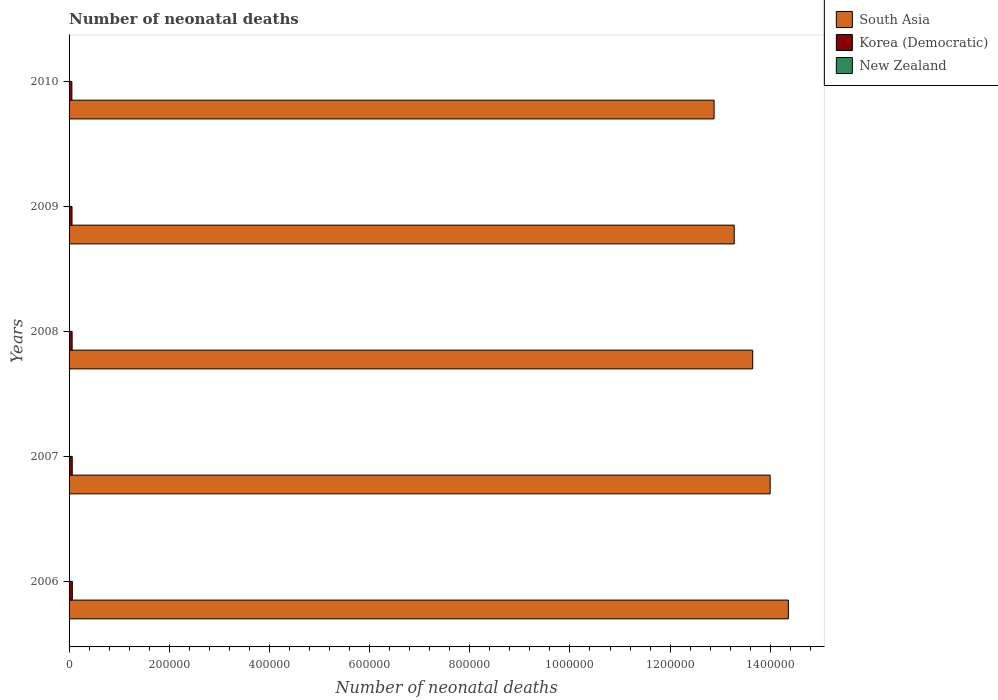How many different coloured bars are there?
Keep it short and to the point. 3. Are the number of bars per tick equal to the number of legend labels?
Offer a very short reply. Yes. How many bars are there on the 2nd tick from the bottom?
Keep it short and to the point. 3. What is the label of the 1st group of bars from the top?
Ensure brevity in your answer.  2010. What is the number of neonatal deaths in in New Zealand in 2007?
Offer a terse response. 189. Across all years, what is the maximum number of neonatal deaths in in New Zealand?
Give a very brief answer. 222. Across all years, what is the minimum number of neonatal deaths in in South Asia?
Your answer should be compact. 1.29e+06. In which year was the number of neonatal deaths in in Korea (Democratic) maximum?
Make the answer very short. 2006. In which year was the number of neonatal deaths in in South Asia minimum?
Provide a succinct answer. 2010. What is the total number of neonatal deaths in in New Zealand in the graph?
Offer a very short reply. 1009. What is the difference between the number of neonatal deaths in in New Zealand in 2006 and that in 2007?
Your answer should be compact. -6. What is the difference between the number of neonatal deaths in in South Asia in 2006 and the number of neonatal deaths in in New Zealand in 2008?
Provide a short and direct response. 1.44e+06. What is the average number of neonatal deaths in in Korea (Democratic) per year?
Your response must be concise. 6083.8. In the year 2007, what is the difference between the number of neonatal deaths in in South Asia and number of neonatal deaths in in Korea (Democratic)?
Offer a terse response. 1.39e+06. In how many years, is the number of neonatal deaths in in Korea (Democratic) greater than 880000 ?
Your response must be concise. 0. What is the ratio of the number of neonatal deaths in in South Asia in 2007 to that in 2010?
Provide a short and direct response. 1.09. What is the difference between the highest and the second highest number of neonatal deaths in in New Zealand?
Your response must be concise. 9. What is the difference between the highest and the lowest number of neonatal deaths in in South Asia?
Ensure brevity in your answer.  1.48e+05. In how many years, is the number of neonatal deaths in in Korea (Democratic) greater than the average number of neonatal deaths in in Korea (Democratic) taken over all years?
Provide a short and direct response. 3. Is the sum of the number of neonatal deaths in in New Zealand in 2008 and 2010 greater than the maximum number of neonatal deaths in in South Asia across all years?
Provide a succinct answer. No. Is it the case that in every year, the sum of the number of neonatal deaths in in Korea (Democratic) and number of neonatal deaths in in South Asia is greater than the number of neonatal deaths in in New Zealand?
Offer a very short reply. Yes. How many bars are there?
Keep it short and to the point. 15. How many years are there in the graph?
Keep it short and to the point. 5. What is the difference between two consecutive major ticks on the X-axis?
Offer a very short reply. 2.00e+05. Does the graph contain grids?
Keep it short and to the point. No. How many legend labels are there?
Your answer should be compact. 3. What is the title of the graph?
Offer a terse response. Number of neonatal deaths. Does "Sub-Saharan Africa (developing only)" appear as one of the legend labels in the graph?
Keep it short and to the point. No. What is the label or title of the X-axis?
Ensure brevity in your answer.  Number of neonatal deaths. What is the Number of neonatal deaths in South Asia in 2006?
Ensure brevity in your answer.  1.44e+06. What is the Number of neonatal deaths in Korea (Democratic) in 2006?
Provide a succinct answer. 6530. What is the Number of neonatal deaths of New Zealand in 2006?
Offer a very short reply. 183. What is the Number of neonatal deaths in South Asia in 2007?
Your answer should be very brief. 1.40e+06. What is the Number of neonatal deaths in Korea (Democratic) in 2007?
Your answer should be compact. 6308. What is the Number of neonatal deaths of New Zealand in 2007?
Keep it short and to the point. 189. What is the Number of neonatal deaths of South Asia in 2008?
Make the answer very short. 1.36e+06. What is the Number of neonatal deaths in Korea (Democratic) in 2008?
Your response must be concise. 6101. What is the Number of neonatal deaths of New Zealand in 2008?
Keep it short and to the point. 202. What is the Number of neonatal deaths of South Asia in 2009?
Provide a succinct answer. 1.33e+06. What is the Number of neonatal deaths in Korea (Democratic) in 2009?
Make the answer very short. 5845. What is the Number of neonatal deaths in New Zealand in 2009?
Provide a succinct answer. 213. What is the Number of neonatal deaths in South Asia in 2010?
Your response must be concise. 1.29e+06. What is the Number of neonatal deaths of Korea (Democratic) in 2010?
Offer a terse response. 5635. What is the Number of neonatal deaths in New Zealand in 2010?
Provide a succinct answer. 222. Across all years, what is the maximum Number of neonatal deaths in South Asia?
Ensure brevity in your answer.  1.44e+06. Across all years, what is the maximum Number of neonatal deaths of Korea (Democratic)?
Offer a terse response. 6530. Across all years, what is the maximum Number of neonatal deaths of New Zealand?
Keep it short and to the point. 222. Across all years, what is the minimum Number of neonatal deaths in South Asia?
Ensure brevity in your answer.  1.29e+06. Across all years, what is the minimum Number of neonatal deaths of Korea (Democratic)?
Ensure brevity in your answer.  5635. Across all years, what is the minimum Number of neonatal deaths of New Zealand?
Your answer should be very brief. 183. What is the total Number of neonatal deaths of South Asia in the graph?
Provide a short and direct response. 6.82e+06. What is the total Number of neonatal deaths in Korea (Democratic) in the graph?
Your answer should be compact. 3.04e+04. What is the total Number of neonatal deaths in New Zealand in the graph?
Keep it short and to the point. 1009. What is the difference between the Number of neonatal deaths in South Asia in 2006 and that in 2007?
Provide a succinct answer. 3.64e+04. What is the difference between the Number of neonatal deaths in Korea (Democratic) in 2006 and that in 2007?
Make the answer very short. 222. What is the difference between the Number of neonatal deaths of New Zealand in 2006 and that in 2007?
Your response must be concise. -6. What is the difference between the Number of neonatal deaths in South Asia in 2006 and that in 2008?
Give a very brief answer. 7.12e+04. What is the difference between the Number of neonatal deaths of Korea (Democratic) in 2006 and that in 2008?
Your response must be concise. 429. What is the difference between the Number of neonatal deaths of New Zealand in 2006 and that in 2008?
Your response must be concise. -19. What is the difference between the Number of neonatal deaths of South Asia in 2006 and that in 2009?
Your response must be concise. 1.08e+05. What is the difference between the Number of neonatal deaths of Korea (Democratic) in 2006 and that in 2009?
Your response must be concise. 685. What is the difference between the Number of neonatal deaths in South Asia in 2006 and that in 2010?
Offer a terse response. 1.48e+05. What is the difference between the Number of neonatal deaths in Korea (Democratic) in 2006 and that in 2010?
Your answer should be compact. 895. What is the difference between the Number of neonatal deaths in New Zealand in 2006 and that in 2010?
Keep it short and to the point. -39. What is the difference between the Number of neonatal deaths in South Asia in 2007 and that in 2008?
Your answer should be compact. 3.48e+04. What is the difference between the Number of neonatal deaths of Korea (Democratic) in 2007 and that in 2008?
Ensure brevity in your answer.  207. What is the difference between the Number of neonatal deaths of New Zealand in 2007 and that in 2008?
Make the answer very short. -13. What is the difference between the Number of neonatal deaths in South Asia in 2007 and that in 2009?
Ensure brevity in your answer.  7.17e+04. What is the difference between the Number of neonatal deaths in Korea (Democratic) in 2007 and that in 2009?
Give a very brief answer. 463. What is the difference between the Number of neonatal deaths in South Asia in 2007 and that in 2010?
Your answer should be very brief. 1.12e+05. What is the difference between the Number of neonatal deaths of Korea (Democratic) in 2007 and that in 2010?
Your answer should be very brief. 673. What is the difference between the Number of neonatal deaths of New Zealand in 2007 and that in 2010?
Ensure brevity in your answer.  -33. What is the difference between the Number of neonatal deaths in South Asia in 2008 and that in 2009?
Your answer should be compact. 3.69e+04. What is the difference between the Number of neonatal deaths in Korea (Democratic) in 2008 and that in 2009?
Your answer should be very brief. 256. What is the difference between the Number of neonatal deaths of South Asia in 2008 and that in 2010?
Provide a short and direct response. 7.71e+04. What is the difference between the Number of neonatal deaths of Korea (Democratic) in 2008 and that in 2010?
Make the answer very short. 466. What is the difference between the Number of neonatal deaths of New Zealand in 2008 and that in 2010?
Offer a very short reply. -20. What is the difference between the Number of neonatal deaths of South Asia in 2009 and that in 2010?
Give a very brief answer. 4.02e+04. What is the difference between the Number of neonatal deaths of Korea (Democratic) in 2009 and that in 2010?
Provide a succinct answer. 210. What is the difference between the Number of neonatal deaths of South Asia in 2006 and the Number of neonatal deaths of Korea (Democratic) in 2007?
Your answer should be compact. 1.43e+06. What is the difference between the Number of neonatal deaths of South Asia in 2006 and the Number of neonatal deaths of New Zealand in 2007?
Make the answer very short. 1.44e+06. What is the difference between the Number of neonatal deaths in Korea (Democratic) in 2006 and the Number of neonatal deaths in New Zealand in 2007?
Keep it short and to the point. 6341. What is the difference between the Number of neonatal deaths of South Asia in 2006 and the Number of neonatal deaths of Korea (Democratic) in 2008?
Your answer should be very brief. 1.43e+06. What is the difference between the Number of neonatal deaths of South Asia in 2006 and the Number of neonatal deaths of New Zealand in 2008?
Provide a succinct answer. 1.44e+06. What is the difference between the Number of neonatal deaths of Korea (Democratic) in 2006 and the Number of neonatal deaths of New Zealand in 2008?
Provide a short and direct response. 6328. What is the difference between the Number of neonatal deaths in South Asia in 2006 and the Number of neonatal deaths in Korea (Democratic) in 2009?
Keep it short and to the point. 1.43e+06. What is the difference between the Number of neonatal deaths in South Asia in 2006 and the Number of neonatal deaths in New Zealand in 2009?
Provide a succinct answer. 1.44e+06. What is the difference between the Number of neonatal deaths of Korea (Democratic) in 2006 and the Number of neonatal deaths of New Zealand in 2009?
Make the answer very short. 6317. What is the difference between the Number of neonatal deaths of South Asia in 2006 and the Number of neonatal deaths of Korea (Democratic) in 2010?
Your answer should be very brief. 1.43e+06. What is the difference between the Number of neonatal deaths of South Asia in 2006 and the Number of neonatal deaths of New Zealand in 2010?
Your answer should be compact. 1.44e+06. What is the difference between the Number of neonatal deaths of Korea (Democratic) in 2006 and the Number of neonatal deaths of New Zealand in 2010?
Keep it short and to the point. 6308. What is the difference between the Number of neonatal deaths of South Asia in 2007 and the Number of neonatal deaths of Korea (Democratic) in 2008?
Ensure brevity in your answer.  1.39e+06. What is the difference between the Number of neonatal deaths of South Asia in 2007 and the Number of neonatal deaths of New Zealand in 2008?
Keep it short and to the point. 1.40e+06. What is the difference between the Number of neonatal deaths in Korea (Democratic) in 2007 and the Number of neonatal deaths in New Zealand in 2008?
Offer a terse response. 6106. What is the difference between the Number of neonatal deaths of South Asia in 2007 and the Number of neonatal deaths of Korea (Democratic) in 2009?
Offer a very short reply. 1.39e+06. What is the difference between the Number of neonatal deaths of South Asia in 2007 and the Number of neonatal deaths of New Zealand in 2009?
Offer a terse response. 1.40e+06. What is the difference between the Number of neonatal deaths in Korea (Democratic) in 2007 and the Number of neonatal deaths in New Zealand in 2009?
Make the answer very short. 6095. What is the difference between the Number of neonatal deaths of South Asia in 2007 and the Number of neonatal deaths of Korea (Democratic) in 2010?
Your answer should be very brief. 1.39e+06. What is the difference between the Number of neonatal deaths of South Asia in 2007 and the Number of neonatal deaths of New Zealand in 2010?
Ensure brevity in your answer.  1.40e+06. What is the difference between the Number of neonatal deaths in Korea (Democratic) in 2007 and the Number of neonatal deaths in New Zealand in 2010?
Keep it short and to the point. 6086. What is the difference between the Number of neonatal deaths of South Asia in 2008 and the Number of neonatal deaths of Korea (Democratic) in 2009?
Your answer should be very brief. 1.36e+06. What is the difference between the Number of neonatal deaths of South Asia in 2008 and the Number of neonatal deaths of New Zealand in 2009?
Offer a very short reply. 1.36e+06. What is the difference between the Number of neonatal deaths of Korea (Democratic) in 2008 and the Number of neonatal deaths of New Zealand in 2009?
Your answer should be very brief. 5888. What is the difference between the Number of neonatal deaths of South Asia in 2008 and the Number of neonatal deaths of Korea (Democratic) in 2010?
Your answer should be compact. 1.36e+06. What is the difference between the Number of neonatal deaths of South Asia in 2008 and the Number of neonatal deaths of New Zealand in 2010?
Make the answer very short. 1.36e+06. What is the difference between the Number of neonatal deaths in Korea (Democratic) in 2008 and the Number of neonatal deaths in New Zealand in 2010?
Keep it short and to the point. 5879. What is the difference between the Number of neonatal deaths in South Asia in 2009 and the Number of neonatal deaths in Korea (Democratic) in 2010?
Your answer should be very brief. 1.32e+06. What is the difference between the Number of neonatal deaths of South Asia in 2009 and the Number of neonatal deaths of New Zealand in 2010?
Provide a short and direct response. 1.33e+06. What is the difference between the Number of neonatal deaths of Korea (Democratic) in 2009 and the Number of neonatal deaths of New Zealand in 2010?
Your answer should be compact. 5623. What is the average Number of neonatal deaths of South Asia per year?
Give a very brief answer. 1.36e+06. What is the average Number of neonatal deaths in Korea (Democratic) per year?
Your answer should be very brief. 6083.8. What is the average Number of neonatal deaths in New Zealand per year?
Your answer should be very brief. 201.8. In the year 2006, what is the difference between the Number of neonatal deaths in South Asia and Number of neonatal deaths in Korea (Democratic)?
Your response must be concise. 1.43e+06. In the year 2006, what is the difference between the Number of neonatal deaths of South Asia and Number of neonatal deaths of New Zealand?
Make the answer very short. 1.44e+06. In the year 2006, what is the difference between the Number of neonatal deaths of Korea (Democratic) and Number of neonatal deaths of New Zealand?
Keep it short and to the point. 6347. In the year 2007, what is the difference between the Number of neonatal deaths of South Asia and Number of neonatal deaths of Korea (Democratic)?
Ensure brevity in your answer.  1.39e+06. In the year 2007, what is the difference between the Number of neonatal deaths of South Asia and Number of neonatal deaths of New Zealand?
Provide a short and direct response. 1.40e+06. In the year 2007, what is the difference between the Number of neonatal deaths in Korea (Democratic) and Number of neonatal deaths in New Zealand?
Your answer should be compact. 6119. In the year 2008, what is the difference between the Number of neonatal deaths in South Asia and Number of neonatal deaths in Korea (Democratic)?
Provide a succinct answer. 1.36e+06. In the year 2008, what is the difference between the Number of neonatal deaths in South Asia and Number of neonatal deaths in New Zealand?
Your answer should be compact. 1.36e+06. In the year 2008, what is the difference between the Number of neonatal deaths of Korea (Democratic) and Number of neonatal deaths of New Zealand?
Your response must be concise. 5899. In the year 2009, what is the difference between the Number of neonatal deaths in South Asia and Number of neonatal deaths in Korea (Democratic)?
Ensure brevity in your answer.  1.32e+06. In the year 2009, what is the difference between the Number of neonatal deaths of South Asia and Number of neonatal deaths of New Zealand?
Provide a succinct answer. 1.33e+06. In the year 2009, what is the difference between the Number of neonatal deaths of Korea (Democratic) and Number of neonatal deaths of New Zealand?
Provide a short and direct response. 5632. In the year 2010, what is the difference between the Number of neonatal deaths in South Asia and Number of neonatal deaths in Korea (Democratic)?
Provide a succinct answer. 1.28e+06. In the year 2010, what is the difference between the Number of neonatal deaths of South Asia and Number of neonatal deaths of New Zealand?
Your response must be concise. 1.29e+06. In the year 2010, what is the difference between the Number of neonatal deaths in Korea (Democratic) and Number of neonatal deaths in New Zealand?
Your response must be concise. 5413. What is the ratio of the Number of neonatal deaths of South Asia in 2006 to that in 2007?
Give a very brief answer. 1.03. What is the ratio of the Number of neonatal deaths of Korea (Democratic) in 2006 to that in 2007?
Keep it short and to the point. 1.04. What is the ratio of the Number of neonatal deaths of New Zealand in 2006 to that in 2007?
Ensure brevity in your answer.  0.97. What is the ratio of the Number of neonatal deaths of South Asia in 2006 to that in 2008?
Provide a succinct answer. 1.05. What is the ratio of the Number of neonatal deaths in Korea (Democratic) in 2006 to that in 2008?
Ensure brevity in your answer.  1.07. What is the ratio of the Number of neonatal deaths of New Zealand in 2006 to that in 2008?
Offer a terse response. 0.91. What is the ratio of the Number of neonatal deaths of South Asia in 2006 to that in 2009?
Offer a terse response. 1.08. What is the ratio of the Number of neonatal deaths of Korea (Democratic) in 2006 to that in 2009?
Make the answer very short. 1.12. What is the ratio of the Number of neonatal deaths in New Zealand in 2006 to that in 2009?
Keep it short and to the point. 0.86. What is the ratio of the Number of neonatal deaths of South Asia in 2006 to that in 2010?
Make the answer very short. 1.12. What is the ratio of the Number of neonatal deaths in Korea (Democratic) in 2006 to that in 2010?
Provide a short and direct response. 1.16. What is the ratio of the Number of neonatal deaths in New Zealand in 2006 to that in 2010?
Make the answer very short. 0.82. What is the ratio of the Number of neonatal deaths in South Asia in 2007 to that in 2008?
Make the answer very short. 1.03. What is the ratio of the Number of neonatal deaths in Korea (Democratic) in 2007 to that in 2008?
Offer a very short reply. 1.03. What is the ratio of the Number of neonatal deaths in New Zealand in 2007 to that in 2008?
Offer a very short reply. 0.94. What is the ratio of the Number of neonatal deaths of South Asia in 2007 to that in 2009?
Offer a terse response. 1.05. What is the ratio of the Number of neonatal deaths in Korea (Democratic) in 2007 to that in 2009?
Your response must be concise. 1.08. What is the ratio of the Number of neonatal deaths in New Zealand in 2007 to that in 2009?
Ensure brevity in your answer.  0.89. What is the ratio of the Number of neonatal deaths of South Asia in 2007 to that in 2010?
Provide a short and direct response. 1.09. What is the ratio of the Number of neonatal deaths in Korea (Democratic) in 2007 to that in 2010?
Make the answer very short. 1.12. What is the ratio of the Number of neonatal deaths in New Zealand in 2007 to that in 2010?
Give a very brief answer. 0.85. What is the ratio of the Number of neonatal deaths in South Asia in 2008 to that in 2009?
Give a very brief answer. 1.03. What is the ratio of the Number of neonatal deaths in Korea (Democratic) in 2008 to that in 2009?
Your answer should be very brief. 1.04. What is the ratio of the Number of neonatal deaths of New Zealand in 2008 to that in 2009?
Your answer should be very brief. 0.95. What is the ratio of the Number of neonatal deaths in South Asia in 2008 to that in 2010?
Offer a terse response. 1.06. What is the ratio of the Number of neonatal deaths in Korea (Democratic) in 2008 to that in 2010?
Provide a short and direct response. 1.08. What is the ratio of the Number of neonatal deaths in New Zealand in 2008 to that in 2010?
Provide a succinct answer. 0.91. What is the ratio of the Number of neonatal deaths of South Asia in 2009 to that in 2010?
Provide a short and direct response. 1.03. What is the ratio of the Number of neonatal deaths of Korea (Democratic) in 2009 to that in 2010?
Give a very brief answer. 1.04. What is the ratio of the Number of neonatal deaths of New Zealand in 2009 to that in 2010?
Give a very brief answer. 0.96. What is the difference between the highest and the second highest Number of neonatal deaths in South Asia?
Ensure brevity in your answer.  3.64e+04. What is the difference between the highest and the second highest Number of neonatal deaths of Korea (Democratic)?
Keep it short and to the point. 222. What is the difference between the highest and the second highest Number of neonatal deaths of New Zealand?
Keep it short and to the point. 9. What is the difference between the highest and the lowest Number of neonatal deaths in South Asia?
Offer a terse response. 1.48e+05. What is the difference between the highest and the lowest Number of neonatal deaths in Korea (Democratic)?
Ensure brevity in your answer.  895. What is the difference between the highest and the lowest Number of neonatal deaths of New Zealand?
Offer a terse response. 39. 